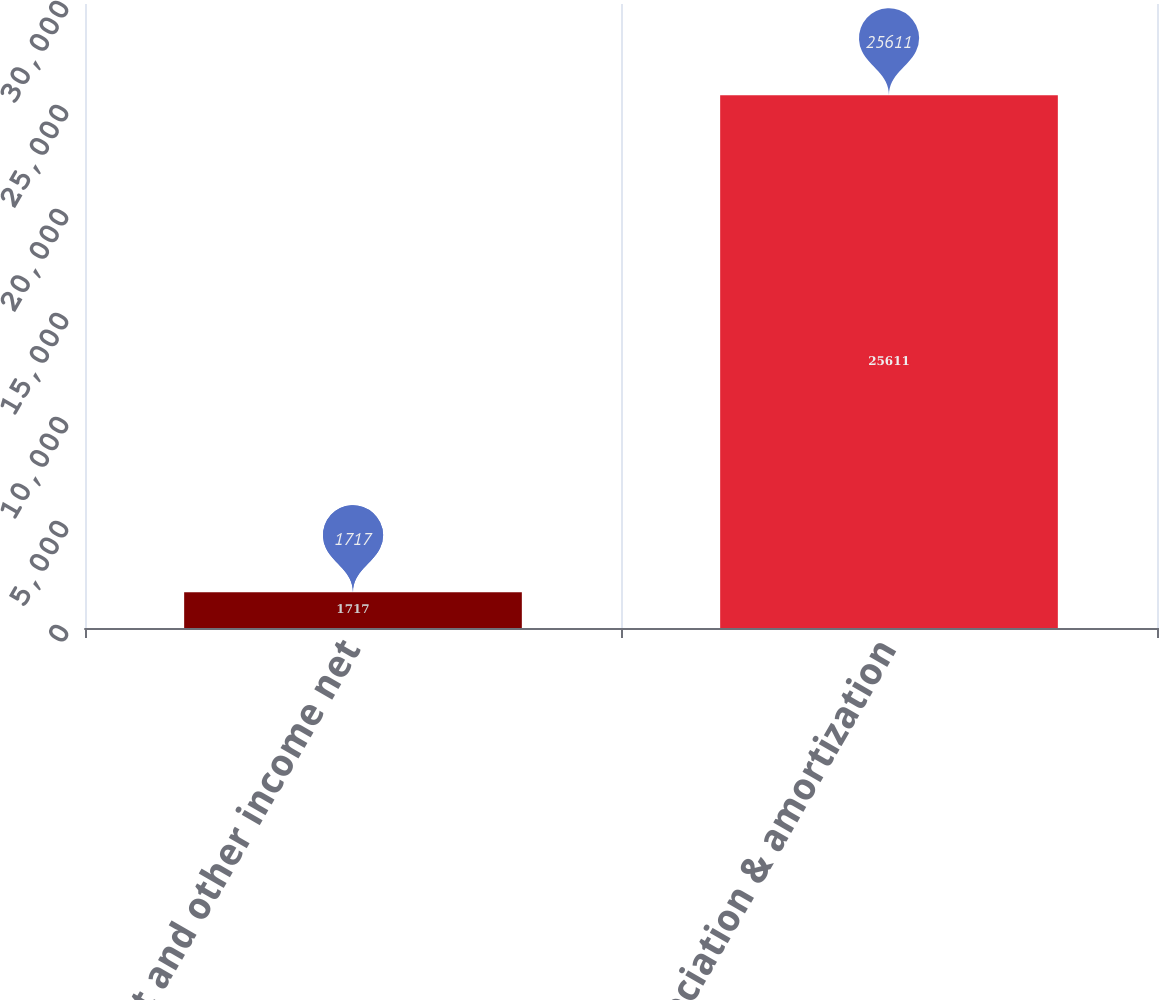Convert chart. <chart><loc_0><loc_0><loc_500><loc_500><bar_chart><fcel>Interest and other income net<fcel>Depreciation & amortization<nl><fcel>1717<fcel>25611<nl></chart> 